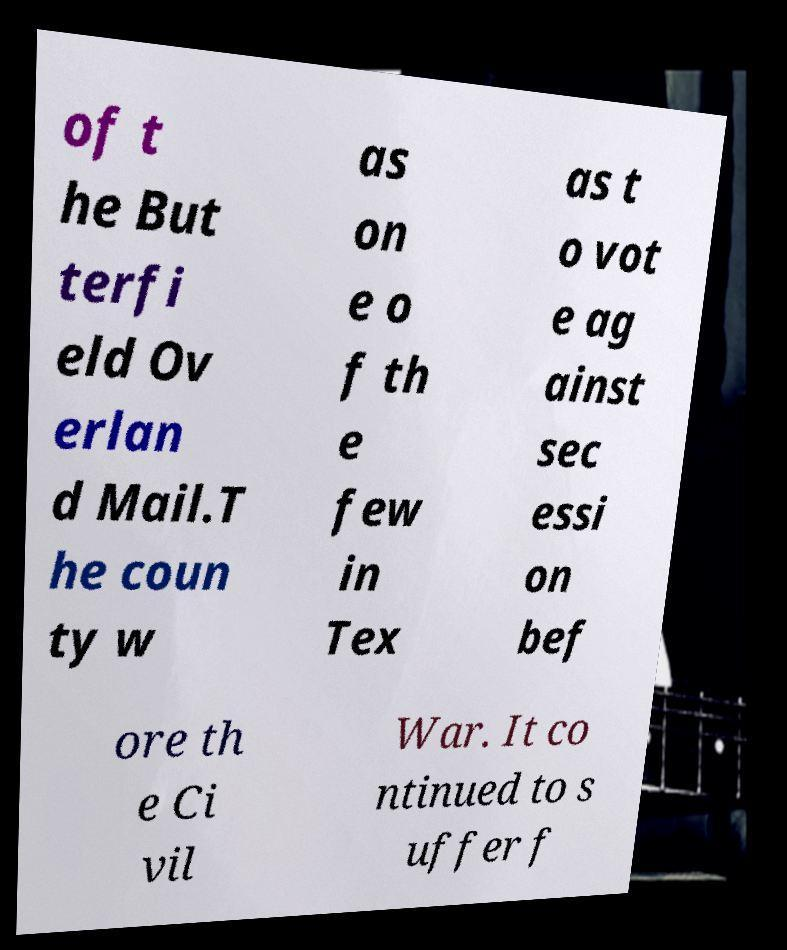I need the written content from this picture converted into text. Can you do that? of t he But terfi eld Ov erlan d Mail.T he coun ty w as on e o f th e few in Tex as t o vot e ag ainst sec essi on bef ore th e Ci vil War. It co ntinued to s uffer f 